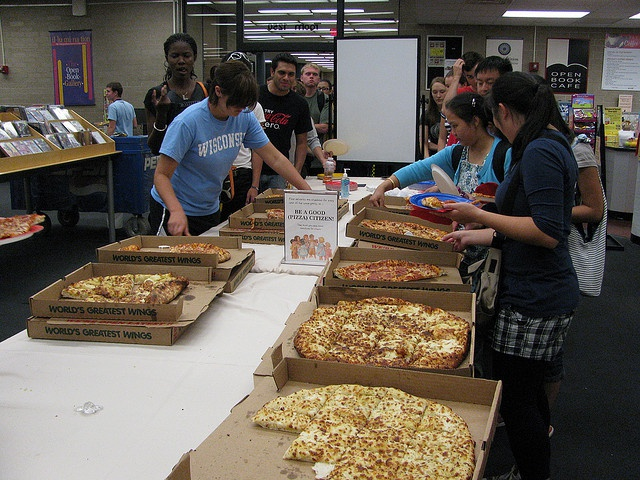Describe the objects in this image and their specific colors. I can see dining table in black, lightgray, and darkgray tones, people in black, maroon, and gray tones, pizza in black, tan, khaki, and olive tones, people in black, blue, and gray tones, and pizza in black, olive, tan, maroon, and gray tones in this image. 